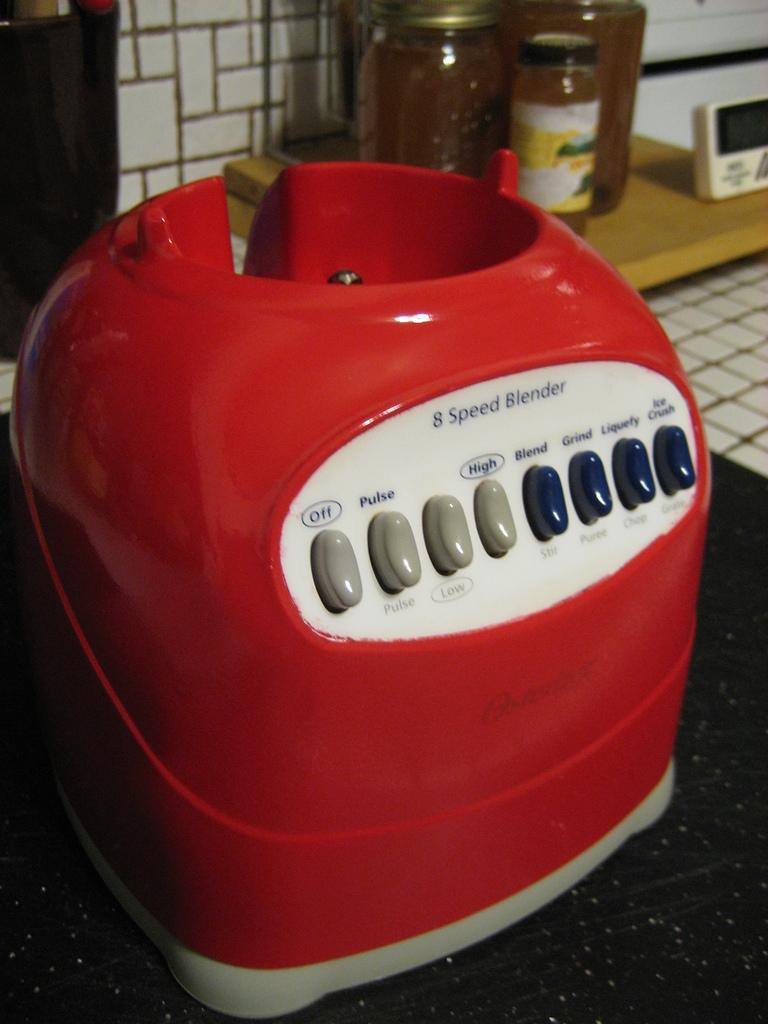<image>
Describe the image concisely. A red and white 8 speed blender without the cup in it. 